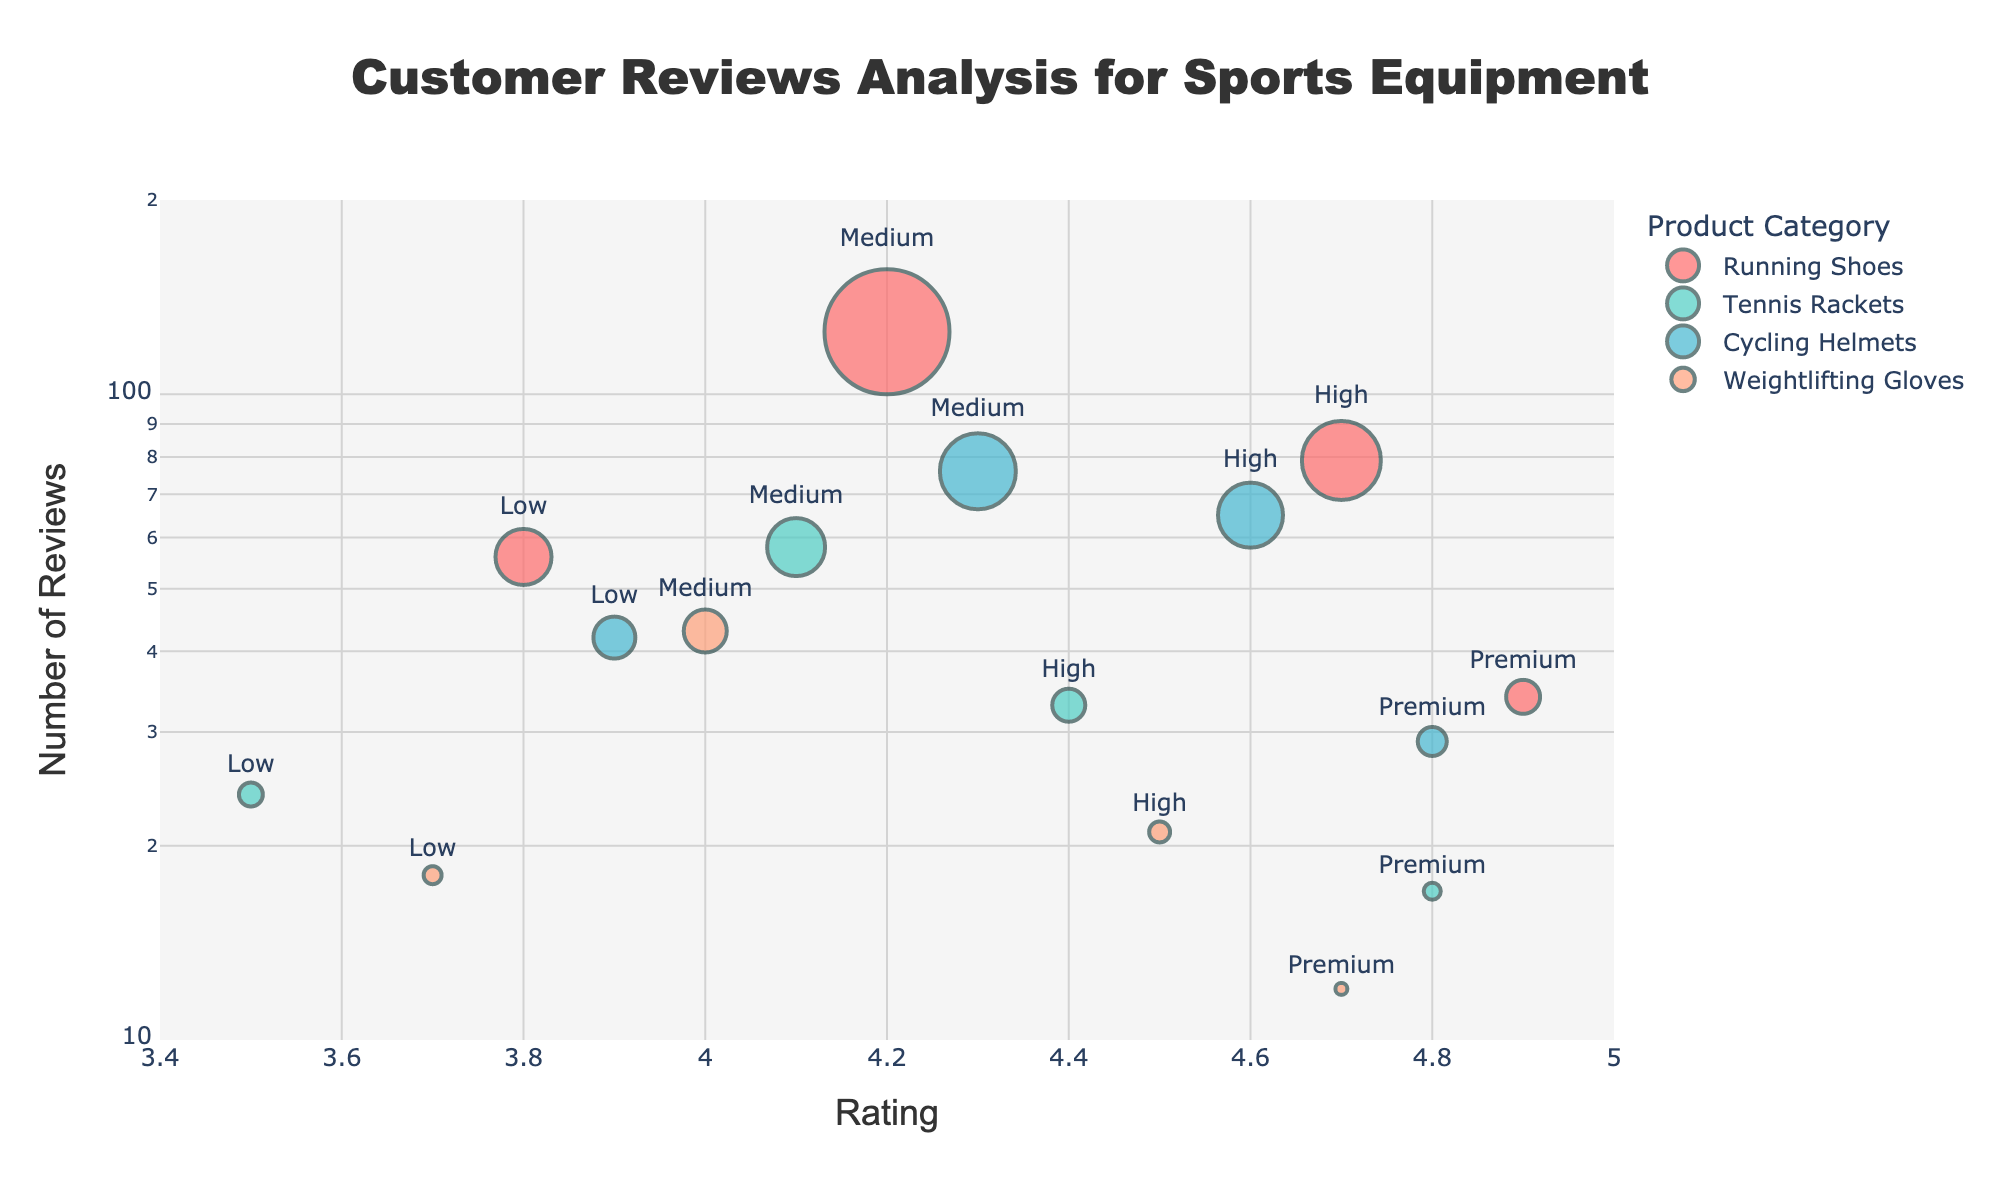Which product category has the highest rating in the Premium price range? By observing the points labeled "Premium" on the x-axis, we can see that the "Running Shoes" has the highest rating near 4.9.
Answer: Running Shoes How many reviews did Running Shoes in the Medium price range receive? Look at the point for Running Shoes labeled "Medium" and check the y-axis value; it aligns with 125.
Answer: 125 What is the color of the markers representing Tennis Rackets? By observing the legend and marker colors, the color for "Tennis Rackets" is a teal-greenish color.
Answer: Teal-Green Which product category has the most consistent ratings across different price ranges? Check for categories with similar ratings across price ranges. Cycling Helmets ratings are consistently high across different price ranges.
Answer: Cycling Helmets What is the rating for Weightlifting Gloves in the Low price range? Locate the Weightlifting Gloves plot with the "Low" label and check its x-axis value which is approximately 3.7.
Answer: 3.7 Among the Premium products, which category has the fewest number of reviews? Identify points labeled "Premium" and compare their y-axis values. Weightlifting Gloves have the least reviews with about 12.
Answer: Weightlifting Gloves What is the lowest rating observed among all product categories and price ranges? By scanning the x-axis values of all points, the lowest rating is approximately 3.5 for Tennis Rackets in the Low price range.
Answer: 3.5 How does the rating trend with price range for Running Shoes? Observing the Running Shoes markers from Low to Premium, the rating increases progressively from 3.8 to 4.9.
Answer: Increases Compare the number of reviews between Running Shoes in the Low and High price ranges. Running Shoes in the Low range have 56 reviews, while in the High range there are 79. The difference is 79 - 56 = 23 more reviews in the High range.
Answer: 23 Which product category has the largest marker size and in which price range? Check the largest markers size-wise in the plot; Running Shoes in the Medium price range have the largest marker size, corresponding to 125 reviews.
Answer: Running Shoes, Medium 